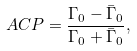<formula> <loc_0><loc_0><loc_500><loc_500>\ A C P = \frac { \Gamma _ { 0 } - \bar { \Gamma } _ { 0 } } { \Gamma _ { 0 } + \bar { \Gamma } _ { 0 } } ,</formula> 